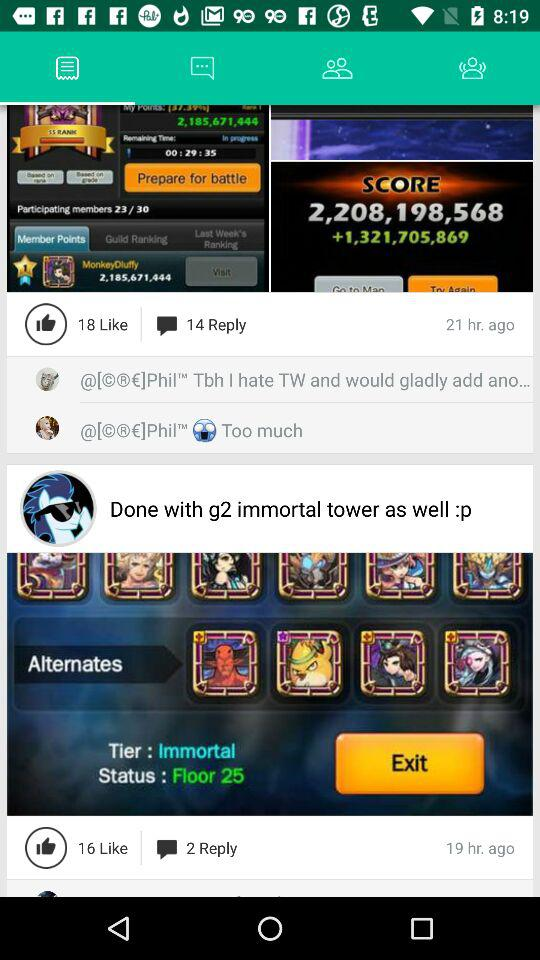What is the status of the floor?
When the provided information is insufficient, respond with <no answer>. <no answer> 